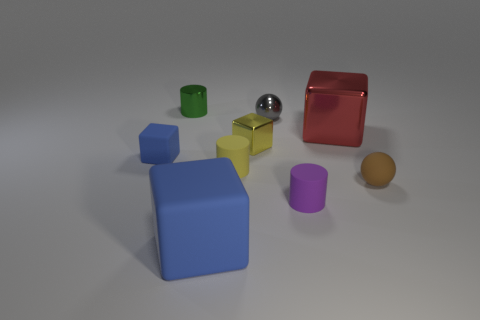Subtract all tiny yellow cubes. How many cubes are left? 3 Subtract all cubes. How many objects are left? 5 Subtract 1 cubes. How many cubes are left? 3 Subtract all yellow blocks. How many blocks are left? 3 Subtract all brown cubes. Subtract all green spheres. How many cubes are left? 4 Subtract all cyan cubes. How many gray balls are left? 1 Subtract all green cylinders. Subtract all tiny matte blocks. How many objects are left? 7 Add 9 tiny metallic cylinders. How many tiny metallic cylinders are left? 10 Add 6 blue matte objects. How many blue matte objects exist? 8 Subtract 0 brown blocks. How many objects are left? 9 